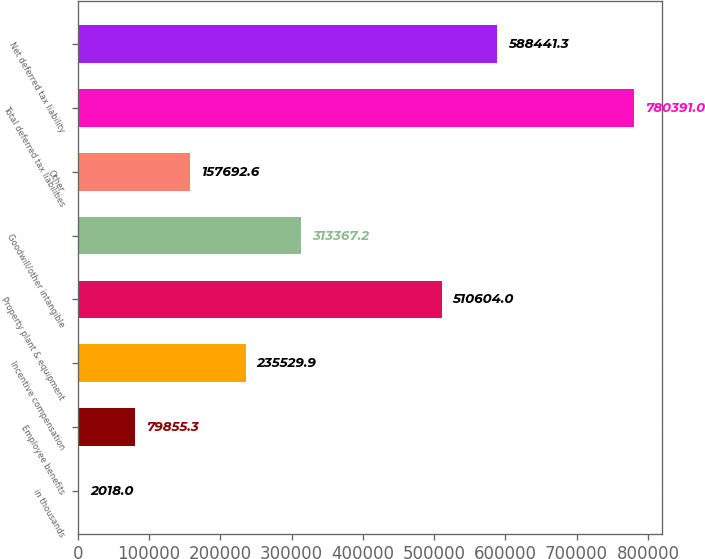Convert chart. <chart><loc_0><loc_0><loc_500><loc_500><bar_chart><fcel>in thousands<fcel>Employee benefits<fcel>Incentive compensation<fcel>Property plant & equipment<fcel>Goodwill/other intangible<fcel>Other<fcel>Total deferred tax liabilities<fcel>Net deferred tax liability<nl><fcel>2018<fcel>79855.3<fcel>235530<fcel>510604<fcel>313367<fcel>157693<fcel>780391<fcel>588441<nl></chart> 